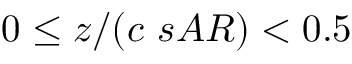Convert formula to latex. <formula><loc_0><loc_0><loc_500><loc_500>0 \leq z / ( c \ s A R ) < 0 . 5</formula> 